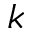Convert formula to latex. <formula><loc_0><loc_0><loc_500><loc_500>k</formula> 